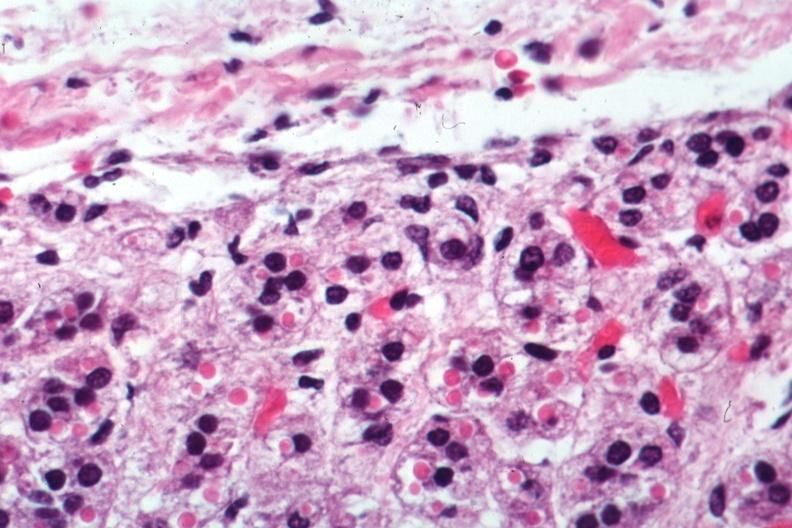what is present?
Answer the question using a single word or phrase. Aldactone bodies 